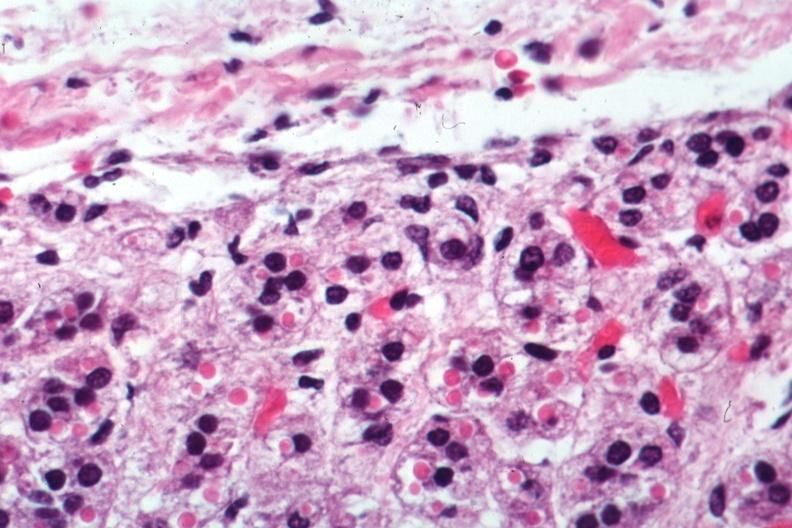what is present?
Answer the question using a single word or phrase. Aldactone bodies 